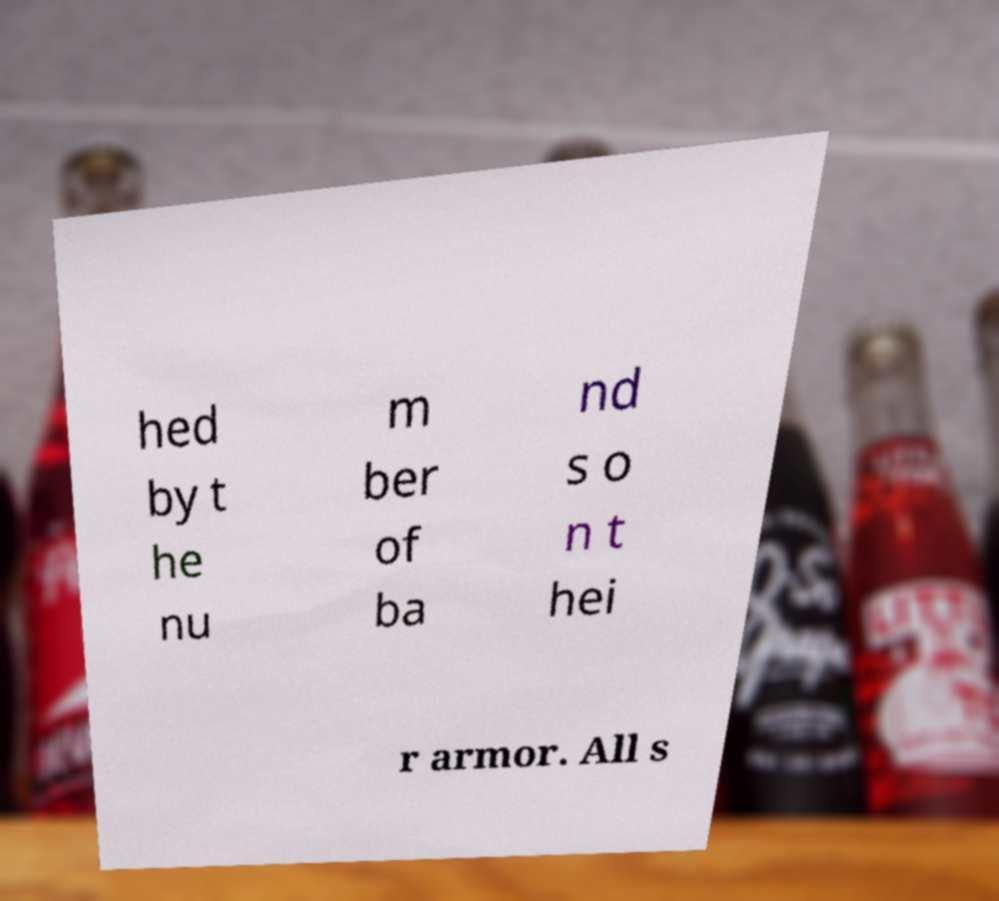What messages or text are displayed in this image? I need them in a readable, typed format. hed by t he nu m ber of ba nd s o n t hei r armor. All s 